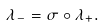<formula> <loc_0><loc_0><loc_500><loc_500>\lambda _ { - } = \sigma \circ \lambda _ { + } .</formula> 